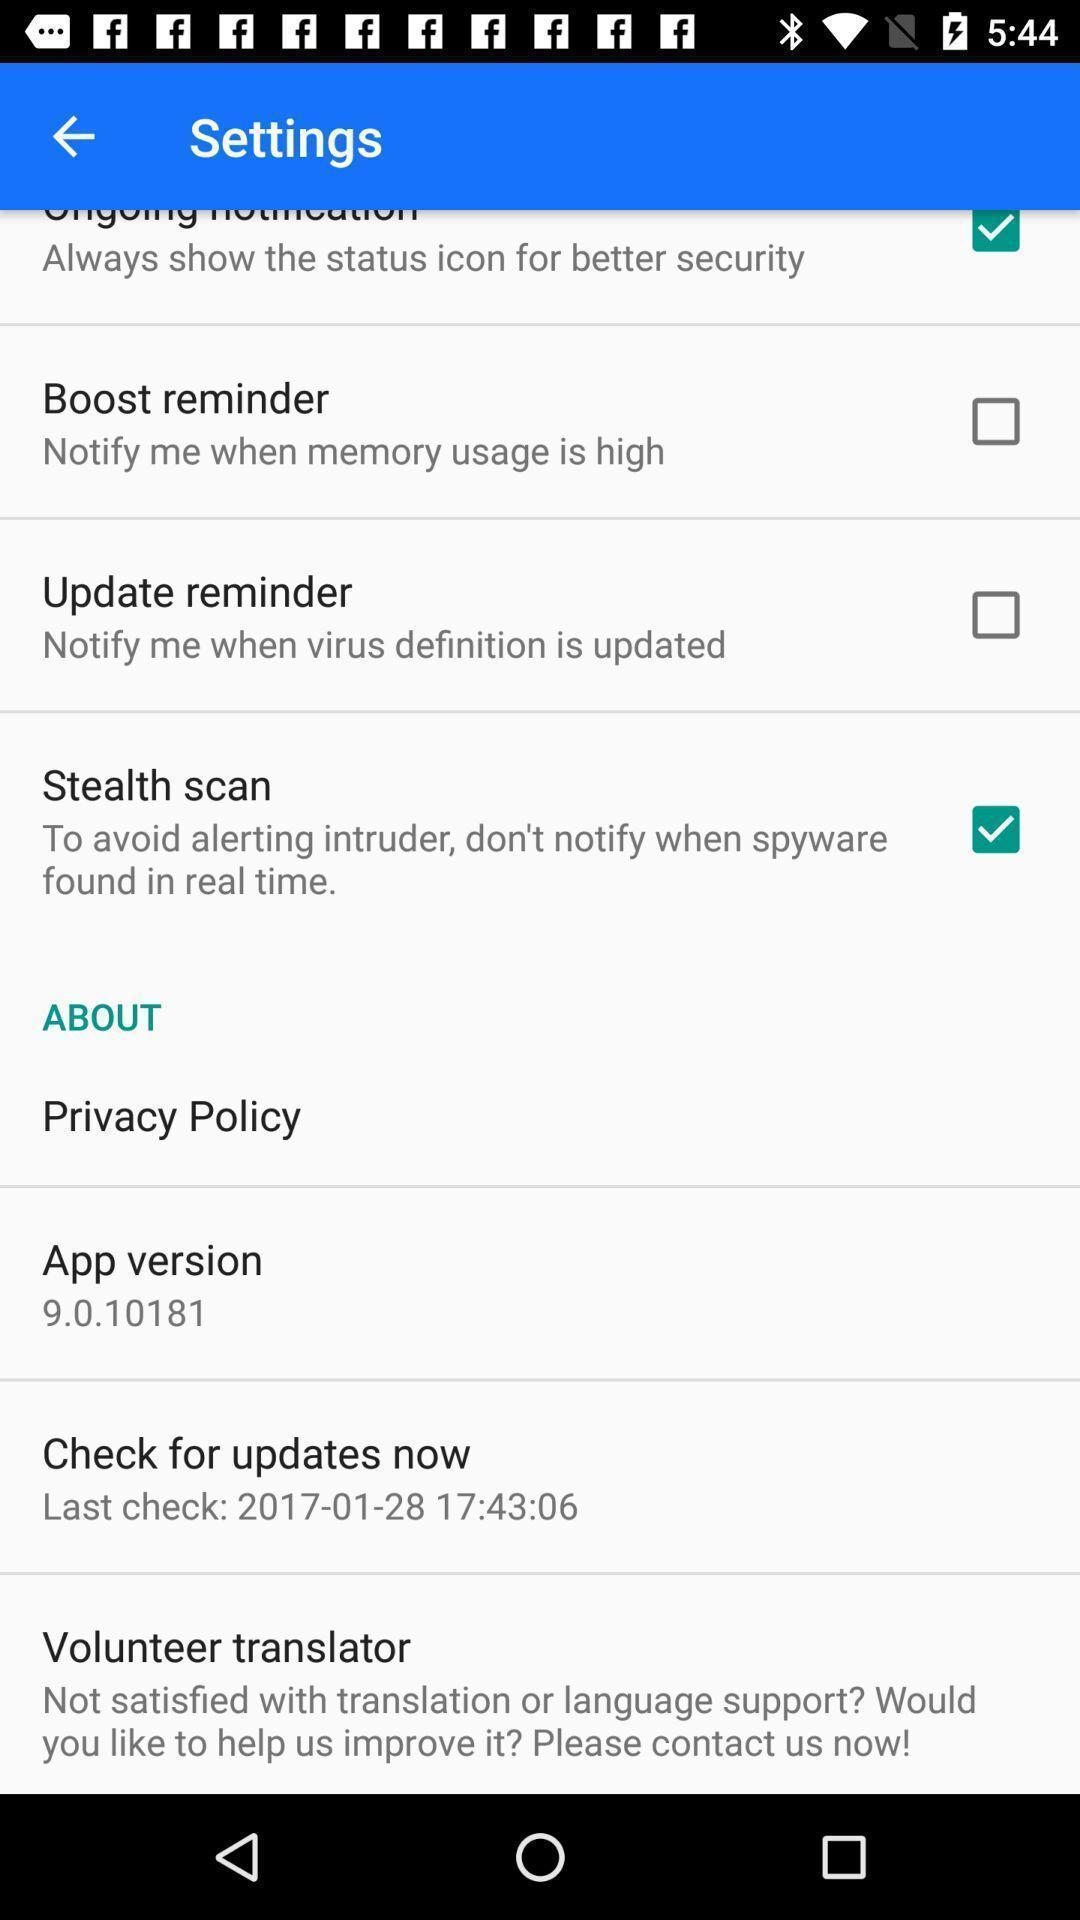Provide a textual representation of this image. Page displaying settings options of the app. 